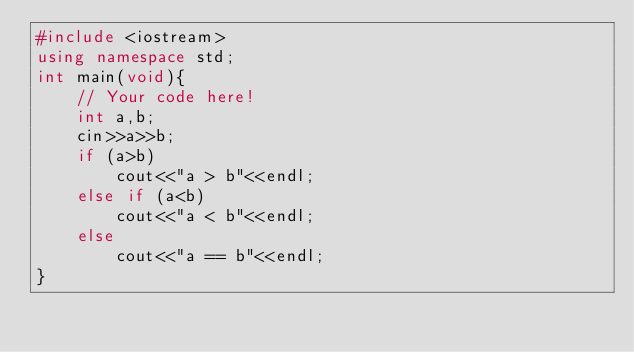<code> <loc_0><loc_0><loc_500><loc_500><_C++_>#include <iostream>
using namespace std;
int main(void){
    // Your code here!
    int a,b;
    cin>>a>>b;
    if (a>b)
        cout<<"a > b"<<endl;
    else if (a<b)
        cout<<"a < b"<<endl;
    else
        cout<<"a == b"<<endl;
}

</code> 